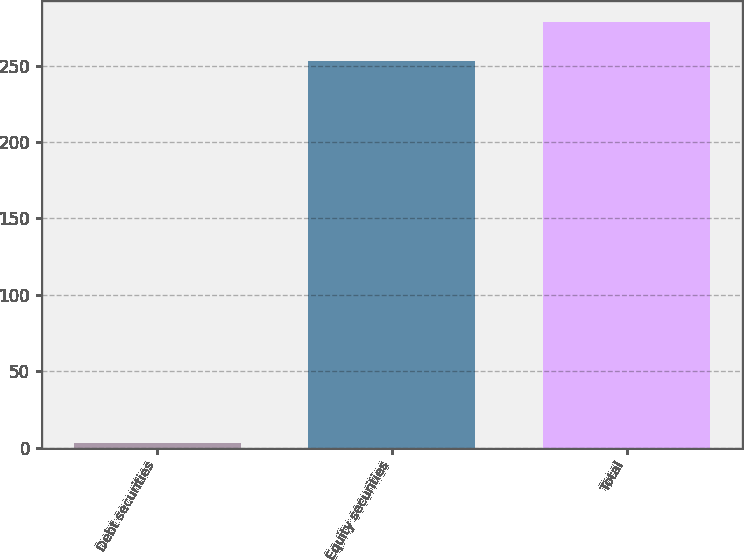Convert chart to OTSL. <chart><loc_0><loc_0><loc_500><loc_500><bar_chart><fcel>Debt securities<fcel>Equity securities<fcel>Total<nl><fcel>3<fcel>253<fcel>278.3<nl></chart> 